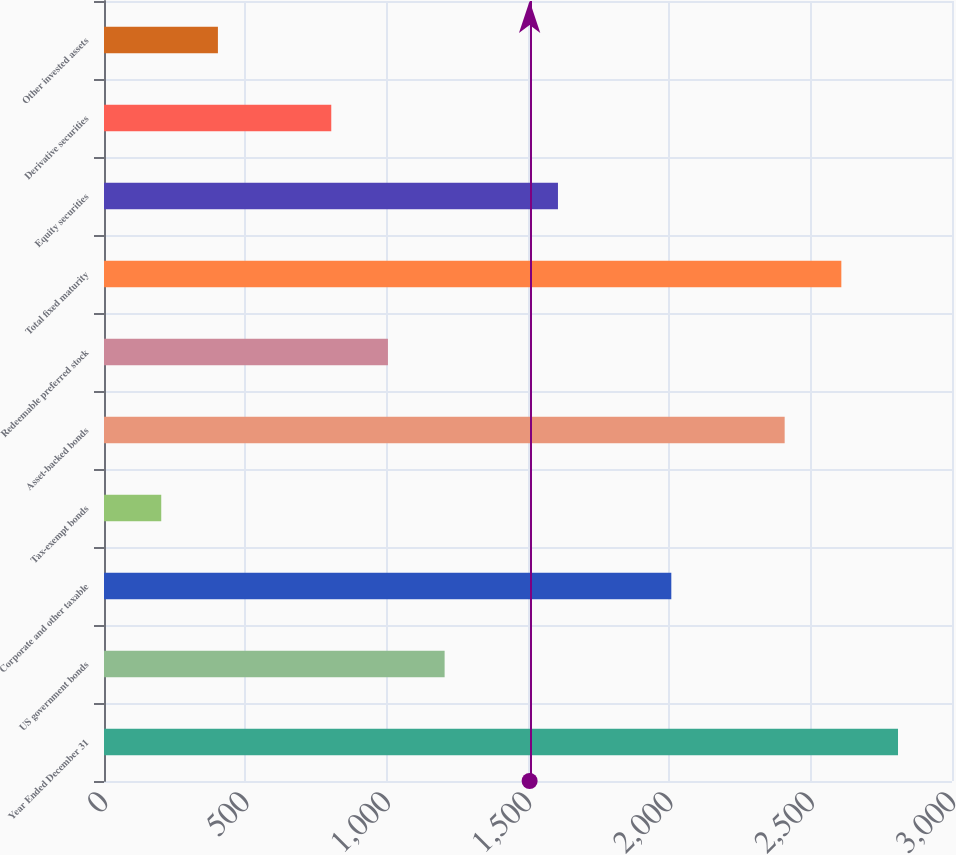<chart> <loc_0><loc_0><loc_500><loc_500><bar_chart><fcel>Year Ended December 31<fcel>US government bonds<fcel>Corporate and other taxable<fcel>Tax-exempt bonds<fcel>Asset-backed bonds<fcel>Redeemable preferred stock<fcel>Total fixed maturity<fcel>Equity securities<fcel>Derivative securities<fcel>Other invested assets<nl><fcel>2809<fcel>1205<fcel>2007<fcel>202.5<fcel>2408<fcel>1004.5<fcel>2608.5<fcel>1606<fcel>804<fcel>403<nl></chart> 